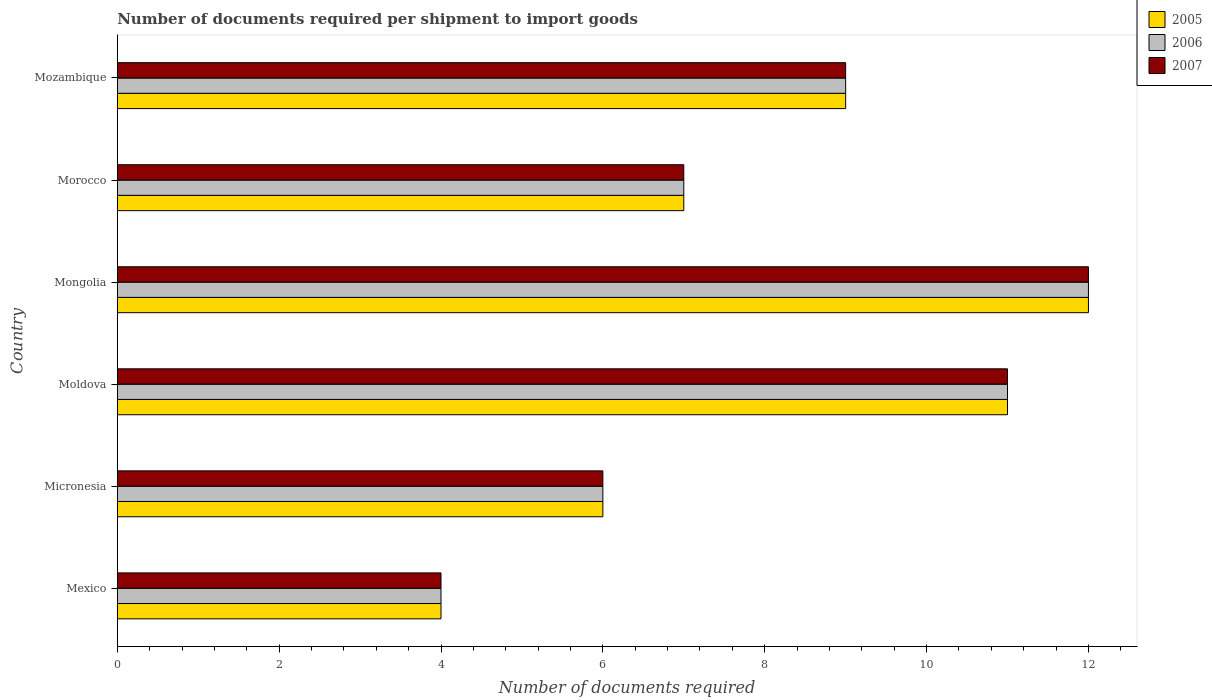How many bars are there on the 6th tick from the top?
Give a very brief answer. 3. What is the label of the 1st group of bars from the top?
Make the answer very short. Mozambique. Across all countries, what is the maximum number of documents required per shipment to import goods in 2005?
Offer a very short reply. 12. Across all countries, what is the minimum number of documents required per shipment to import goods in 2005?
Offer a terse response. 4. In which country was the number of documents required per shipment to import goods in 2006 maximum?
Offer a terse response. Mongolia. In which country was the number of documents required per shipment to import goods in 2005 minimum?
Provide a succinct answer. Mexico. What is the total number of documents required per shipment to import goods in 2005 in the graph?
Provide a succinct answer. 49. What is the difference between the number of documents required per shipment to import goods in 2007 in Mexico and that in Mongolia?
Keep it short and to the point. -8. What is the difference between the number of documents required per shipment to import goods in 2006 in Mongolia and the number of documents required per shipment to import goods in 2005 in Micronesia?
Your answer should be very brief. 6. What is the average number of documents required per shipment to import goods in 2006 per country?
Your answer should be compact. 8.17. What is the difference between the number of documents required per shipment to import goods in 2005 and number of documents required per shipment to import goods in 2006 in Mozambique?
Offer a terse response. 0. In how many countries, is the number of documents required per shipment to import goods in 2006 greater than 10.8 ?
Your answer should be compact. 2. What is the ratio of the number of documents required per shipment to import goods in 2007 in Mongolia to that in Morocco?
Ensure brevity in your answer.  1.71. Is the difference between the number of documents required per shipment to import goods in 2005 in Mexico and Micronesia greater than the difference between the number of documents required per shipment to import goods in 2006 in Mexico and Micronesia?
Your answer should be compact. No. What is the difference between the highest and the second highest number of documents required per shipment to import goods in 2006?
Offer a terse response. 1. What is the difference between the highest and the lowest number of documents required per shipment to import goods in 2005?
Provide a short and direct response. 8. What does the 2nd bar from the top in Moldova represents?
Provide a short and direct response. 2006. What is the difference between two consecutive major ticks on the X-axis?
Provide a succinct answer. 2. Does the graph contain any zero values?
Your response must be concise. No. Does the graph contain grids?
Make the answer very short. No. What is the title of the graph?
Offer a terse response. Number of documents required per shipment to import goods. What is the label or title of the X-axis?
Your response must be concise. Number of documents required. What is the Number of documents required of 2005 in Mexico?
Your answer should be compact. 4. What is the Number of documents required in 2007 in Mexico?
Provide a short and direct response. 4. What is the Number of documents required in 2006 in Micronesia?
Make the answer very short. 6. What is the Number of documents required of 2005 in Moldova?
Give a very brief answer. 11. What is the Number of documents required of 2007 in Moldova?
Provide a succinct answer. 11. What is the Number of documents required of 2005 in Mongolia?
Make the answer very short. 12. What is the Number of documents required of 2007 in Mongolia?
Ensure brevity in your answer.  12. What is the Number of documents required in 2005 in Morocco?
Your response must be concise. 7. What is the Number of documents required of 2006 in Morocco?
Keep it short and to the point. 7. What is the Number of documents required of 2007 in Morocco?
Give a very brief answer. 7. What is the Number of documents required in 2005 in Mozambique?
Offer a terse response. 9. What is the Number of documents required in 2007 in Mozambique?
Give a very brief answer. 9. Across all countries, what is the maximum Number of documents required of 2007?
Make the answer very short. 12. Across all countries, what is the minimum Number of documents required in 2005?
Your answer should be very brief. 4. What is the total Number of documents required of 2005 in the graph?
Offer a very short reply. 49. What is the difference between the Number of documents required in 2005 in Mexico and that in Micronesia?
Ensure brevity in your answer.  -2. What is the difference between the Number of documents required in 2006 in Mexico and that in Micronesia?
Offer a terse response. -2. What is the difference between the Number of documents required in 2005 in Mexico and that in Moldova?
Offer a very short reply. -7. What is the difference between the Number of documents required in 2007 in Mexico and that in Moldova?
Offer a very short reply. -7. What is the difference between the Number of documents required of 2007 in Mexico and that in Mongolia?
Your answer should be very brief. -8. What is the difference between the Number of documents required of 2005 in Mexico and that in Morocco?
Keep it short and to the point. -3. What is the difference between the Number of documents required in 2006 in Mexico and that in Morocco?
Your response must be concise. -3. What is the difference between the Number of documents required in 2007 in Mexico and that in Morocco?
Ensure brevity in your answer.  -3. What is the difference between the Number of documents required of 2005 in Mexico and that in Mozambique?
Your answer should be very brief. -5. What is the difference between the Number of documents required in 2005 in Micronesia and that in Moldova?
Offer a very short reply. -5. What is the difference between the Number of documents required of 2006 in Micronesia and that in Moldova?
Your response must be concise. -5. What is the difference between the Number of documents required in 2005 in Micronesia and that in Mongolia?
Keep it short and to the point. -6. What is the difference between the Number of documents required in 2006 in Micronesia and that in Mongolia?
Provide a short and direct response. -6. What is the difference between the Number of documents required of 2007 in Micronesia and that in Mongolia?
Ensure brevity in your answer.  -6. What is the difference between the Number of documents required of 2005 in Micronesia and that in Morocco?
Your answer should be very brief. -1. What is the difference between the Number of documents required of 2006 in Micronesia and that in Morocco?
Your answer should be very brief. -1. What is the difference between the Number of documents required in 2007 in Micronesia and that in Morocco?
Provide a succinct answer. -1. What is the difference between the Number of documents required in 2007 in Micronesia and that in Mozambique?
Your answer should be compact. -3. What is the difference between the Number of documents required of 2006 in Moldova and that in Mongolia?
Offer a terse response. -1. What is the difference between the Number of documents required in 2006 in Mongolia and that in Morocco?
Offer a very short reply. 5. What is the difference between the Number of documents required of 2005 in Mongolia and that in Mozambique?
Your answer should be compact. 3. What is the difference between the Number of documents required in 2006 in Mongolia and that in Mozambique?
Keep it short and to the point. 3. What is the difference between the Number of documents required of 2005 in Morocco and that in Mozambique?
Make the answer very short. -2. What is the difference between the Number of documents required in 2006 in Morocco and that in Mozambique?
Provide a short and direct response. -2. What is the difference between the Number of documents required of 2005 in Mexico and the Number of documents required of 2007 in Micronesia?
Make the answer very short. -2. What is the difference between the Number of documents required of 2006 in Mexico and the Number of documents required of 2007 in Micronesia?
Give a very brief answer. -2. What is the difference between the Number of documents required in 2005 in Mexico and the Number of documents required in 2006 in Mongolia?
Ensure brevity in your answer.  -8. What is the difference between the Number of documents required in 2006 in Mexico and the Number of documents required in 2007 in Mongolia?
Give a very brief answer. -8. What is the difference between the Number of documents required in 2005 in Mexico and the Number of documents required in 2006 in Morocco?
Your answer should be very brief. -3. What is the difference between the Number of documents required of 2005 in Mexico and the Number of documents required of 2007 in Morocco?
Your answer should be compact. -3. What is the difference between the Number of documents required in 2005 in Mexico and the Number of documents required in 2006 in Mozambique?
Your answer should be compact. -5. What is the difference between the Number of documents required of 2005 in Micronesia and the Number of documents required of 2006 in Moldova?
Your answer should be compact. -5. What is the difference between the Number of documents required in 2005 in Micronesia and the Number of documents required in 2007 in Moldova?
Provide a short and direct response. -5. What is the difference between the Number of documents required of 2006 in Micronesia and the Number of documents required of 2007 in Moldova?
Ensure brevity in your answer.  -5. What is the difference between the Number of documents required of 2005 in Micronesia and the Number of documents required of 2007 in Mongolia?
Your answer should be very brief. -6. What is the difference between the Number of documents required of 2006 in Micronesia and the Number of documents required of 2007 in Mongolia?
Your response must be concise. -6. What is the difference between the Number of documents required in 2005 in Micronesia and the Number of documents required in 2006 in Morocco?
Keep it short and to the point. -1. What is the difference between the Number of documents required of 2006 in Micronesia and the Number of documents required of 2007 in Mozambique?
Ensure brevity in your answer.  -3. What is the difference between the Number of documents required in 2006 in Moldova and the Number of documents required in 2007 in Mongolia?
Provide a succinct answer. -1. What is the difference between the Number of documents required of 2005 in Moldova and the Number of documents required of 2007 in Morocco?
Give a very brief answer. 4. What is the difference between the Number of documents required of 2006 in Moldova and the Number of documents required of 2007 in Morocco?
Your answer should be compact. 4. What is the difference between the Number of documents required in 2005 in Moldova and the Number of documents required in 2007 in Mozambique?
Ensure brevity in your answer.  2. What is the difference between the Number of documents required in 2006 in Moldova and the Number of documents required in 2007 in Mozambique?
Offer a very short reply. 2. What is the difference between the Number of documents required in 2005 in Mongolia and the Number of documents required in 2006 in Mozambique?
Offer a very short reply. 3. What is the average Number of documents required in 2005 per country?
Offer a terse response. 8.17. What is the average Number of documents required of 2006 per country?
Keep it short and to the point. 8.17. What is the average Number of documents required in 2007 per country?
Provide a short and direct response. 8.17. What is the difference between the Number of documents required in 2005 and Number of documents required in 2007 in Mexico?
Your answer should be very brief. 0. What is the difference between the Number of documents required of 2005 and Number of documents required of 2006 in Micronesia?
Your response must be concise. 0. What is the difference between the Number of documents required of 2005 and Number of documents required of 2006 in Moldova?
Your response must be concise. 0. What is the difference between the Number of documents required of 2005 and Number of documents required of 2007 in Moldova?
Ensure brevity in your answer.  0. What is the difference between the Number of documents required of 2005 and Number of documents required of 2006 in Mongolia?
Keep it short and to the point. 0. What is the difference between the Number of documents required of 2005 and Number of documents required of 2007 in Mongolia?
Ensure brevity in your answer.  0. What is the difference between the Number of documents required in 2005 and Number of documents required in 2006 in Morocco?
Your answer should be very brief. 0. What is the difference between the Number of documents required of 2005 and Number of documents required of 2006 in Mozambique?
Ensure brevity in your answer.  0. What is the ratio of the Number of documents required of 2005 in Mexico to that in Micronesia?
Offer a very short reply. 0.67. What is the ratio of the Number of documents required in 2005 in Mexico to that in Moldova?
Offer a very short reply. 0.36. What is the ratio of the Number of documents required of 2006 in Mexico to that in Moldova?
Offer a very short reply. 0.36. What is the ratio of the Number of documents required of 2007 in Mexico to that in Moldova?
Your answer should be compact. 0.36. What is the ratio of the Number of documents required in 2006 in Mexico to that in Mongolia?
Provide a succinct answer. 0.33. What is the ratio of the Number of documents required in 2006 in Mexico to that in Morocco?
Make the answer very short. 0.57. What is the ratio of the Number of documents required of 2007 in Mexico to that in Morocco?
Give a very brief answer. 0.57. What is the ratio of the Number of documents required of 2005 in Mexico to that in Mozambique?
Your answer should be compact. 0.44. What is the ratio of the Number of documents required of 2006 in Mexico to that in Mozambique?
Make the answer very short. 0.44. What is the ratio of the Number of documents required in 2007 in Mexico to that in Mozambique?
Ensure brevity in your answer.  0.44. What is the ratio of the Number of documents required of 2005 in Micronesia to that in Moldova?
Keep it short and to the point. 0.55. What is the ratio of the Number of documents required of 2006 in Micronesia to that in Moldova?
Keep it short and to the point. 0.55. What is the ratio of the Number of documents required in 2007 in Micronesia to that in Moldova?
Your answer should be compact. 0.55. What is the ratio of the Number of documents required of 2005 in Micronesia to that in Mongolia?
Ensure brevity in your answer.  0.5. What is the ratio of the Number of documents required in 2006 in Micronesia to that in Morocco?
Offer a terse response. 0.86. What is the ratio of the Number of documents required of 2005 in Micronesia to that in Mozambique?
Make the answer very short. 0.67. What is the ratio of the Number of documents required of 2006 in Moldova to that in Mongolia?
Your answer should be very brief. 0.92. What is the ratio of the Number of documents required in 2007 in Moldova to that in Mongolia?
Provide a short and direct response. 0.92. What is the ratio of the Number of documents required of 2005 in Moldova to that in Morocco?
Your response must be concise. 1.57. What is the ratio of the Number of documents required in 2006 in Moldova to that in Morocco?
Offer a terse response. 1.57. What is the ratio of the Number of documents required in 2007 in Moldova to that in Morocco?
Your answer should be very brief. 1.57. What is the ratio of the Number of documents required in 2005 in Moldova to that in Mozambique?
Keep it short and to the point. 1.22. What is the ratio of the Number of documents required in 2006 in Moldova to that in Mozambique?
Ensure brevity in your answer.  1.22. What is the ratio of the Number of documents required of 2007 in Moldova to that in Mozambique?
Your response must be concise. 1.22. What is the ratio of the Number of documents required of 2005 in Mongolia to that in Morocco?
Ensure brevity in your answer.  1.71. What is the ratio of the Number of documents required of 2006 in Mongolia to that in Morocco?
Ensure brevity in your answer.  1.71. What is the ratio of the Number of documents required of 2007 in Mongolia to that in Morocco?
Provide a short and direct response. 1.71. What is the ratio of the Number of documents required in 2005 in Morocco to that in Mozambique?
Provide a succinct answer. 0.78. What is the ratio of the Number of documents required in 2006 in Morocco to that in Mozambique?
Your answer should be very brief. 0.78. What is the ratio of the Number of documents required in 2007 in Morocco to that in Mozambique?
Make the answer very short. 0.78. What is the difference between the highest and the second highest Number of documents required in 2005?
Keep it short and to the point. 1. What is the difference between the highest and the second highest Number of documents required of 2006?
Give a very brief answer. 1. What is the difference between the highest and the lowest Number of documents required in 2005?
Your answer should be compact. 8. 